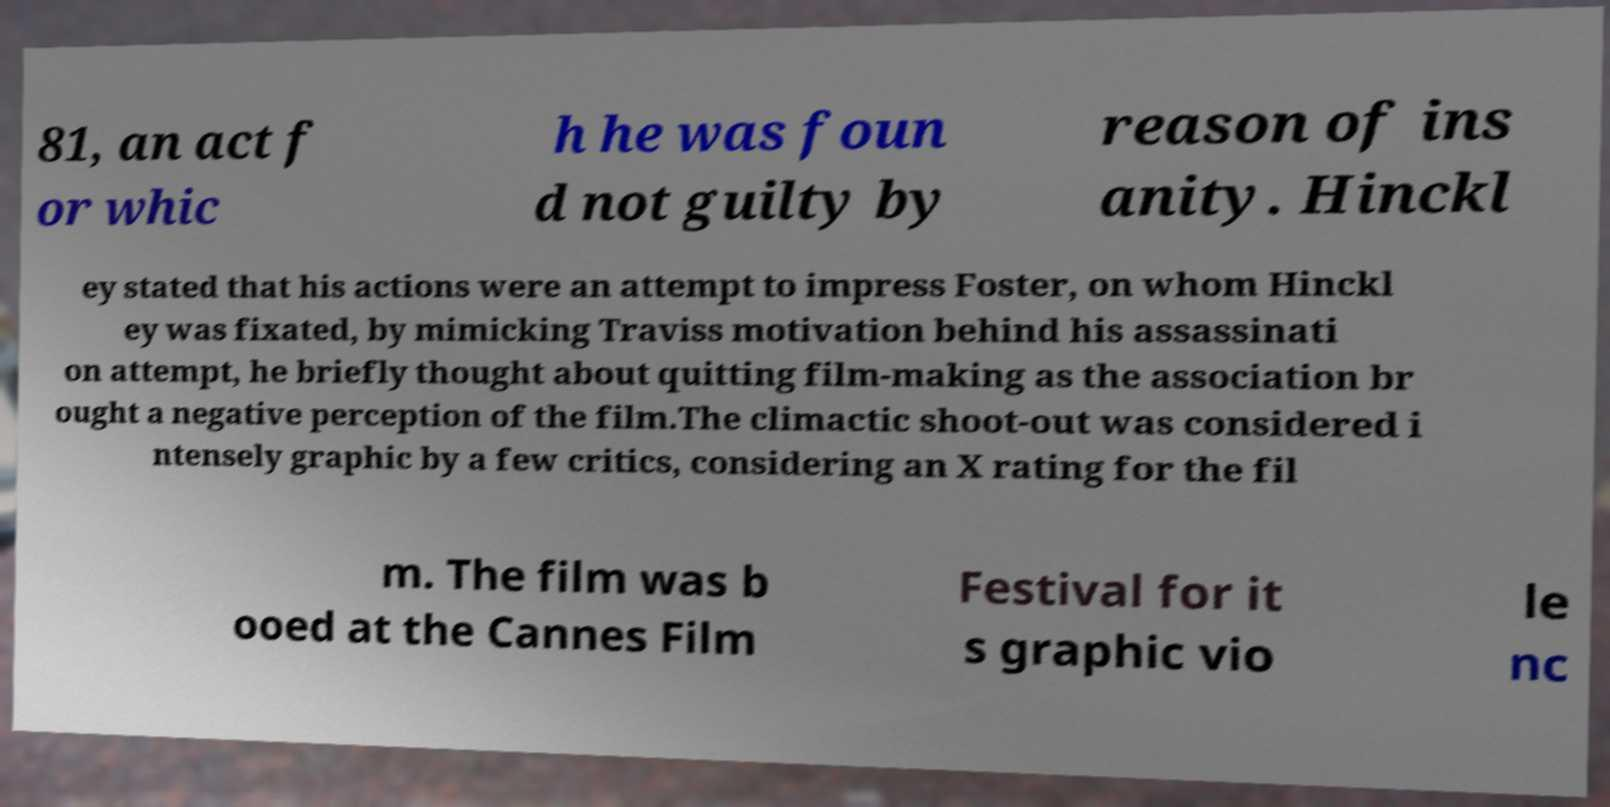Can you accurately transcribe the text from the provided image for me? 81, an act f or whic h he was foun d not guilty by reason of ins anity. Hinckl ey stated that his actions were an attempt to impress Foster, on whom Hinckl ey was fixated, by mimicking Traviss motivation behind his assassinati on attempt, he briefly thought about quitting film-making as the association br ought a negative perception of the film.The climactic shoot-out was considered i ntensely graphic by a few critics, considering an X rating for the fil m. The film was b ooed at the Cannes Film Festival for it s graphic vio le nc 